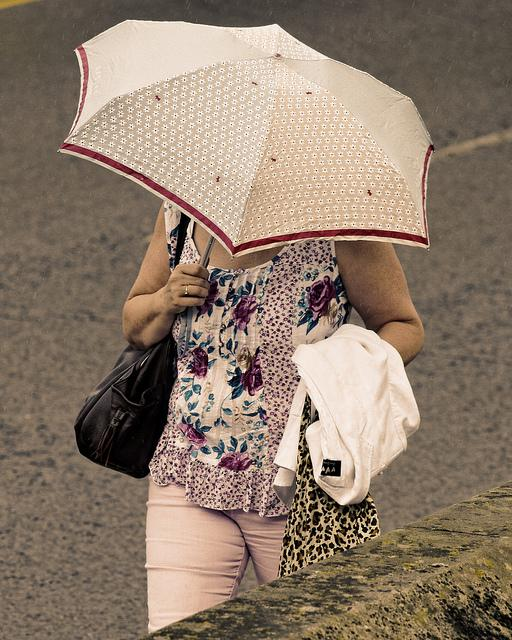Why is she holding an umbrella in dry weather?

Choices:
A) sun protection
B) is hiding
C) confused
D) likes umbrellas sun protection 